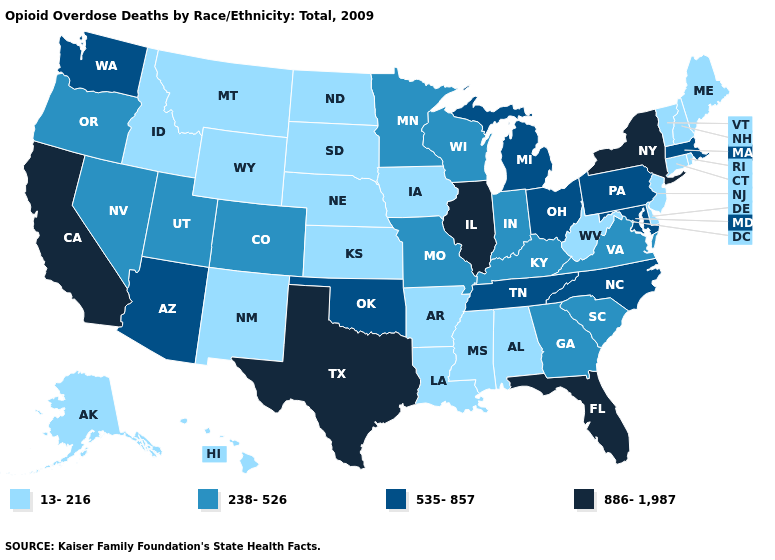Does Indiana have the lowest value in the MidWest?
Write a very short answer. No. Name the states that have a value in the range 238-526?
Quick response, please. Colorado, Georgia, Indiana, Kentucky, Minnesota, Missouri, Nevada, Oregon, South Carolina, Utah, Virginia, Wisconsin. How many symbols are there in the legend?
Give a very brief answer. 4. Name the states that have a value in the range 535-857?
Answer briefly. Arizona, Maryland, Massachusetts, Michigan, North Carolina, Ohio, Oklahoma, Pennsylvania, Tennessee, Washington. Name the states that have a value in the range 238-526?
Keep it brief. Colorado, Georgia, Indiana, Kentucky, Minnesota, Missouri, Nevada, Oregon, South Carolina, Utah, Virginia, Wisconsin. Among the states that border Maryland , does West Virginia have the lowest value?
Be succinct. Yes. What is the highest value in the USA?
Quick response, please. 886-1,987. How many symbols are there in the legend?
Answer briefly. 4. Which states have the lowest value in the USA?
Be succinct. Alabama, Alaska, Arkansas, Connecticut, Delaware, Hawaii, Idaho, Iowa, Kansas, Louisiana, Maine, Mississippi, Montana, Nebraska, New Hampshire, New Jersey, New Mexico, North Dakota, Rhode Island, South Dakota, Vermont, West Virginia, Wyoming. Among the states that border Louisiana , which have the lowest value?
Answer briefly. Arkansas, Mississippi. Name the states that have a value in the range 886-1,987?
Give a very brief answer. California, Florida, Illinois, New York, Texas. Does South Dakota have the lowest value in the USA?
Be succinct. Yes. What is the value of Indiana?
Be succinct. 238-526. Does Vermont have the same value as Oregon?
Concise answer only. No. What is the value of Colorado?
Quick response, please. 238-526. 